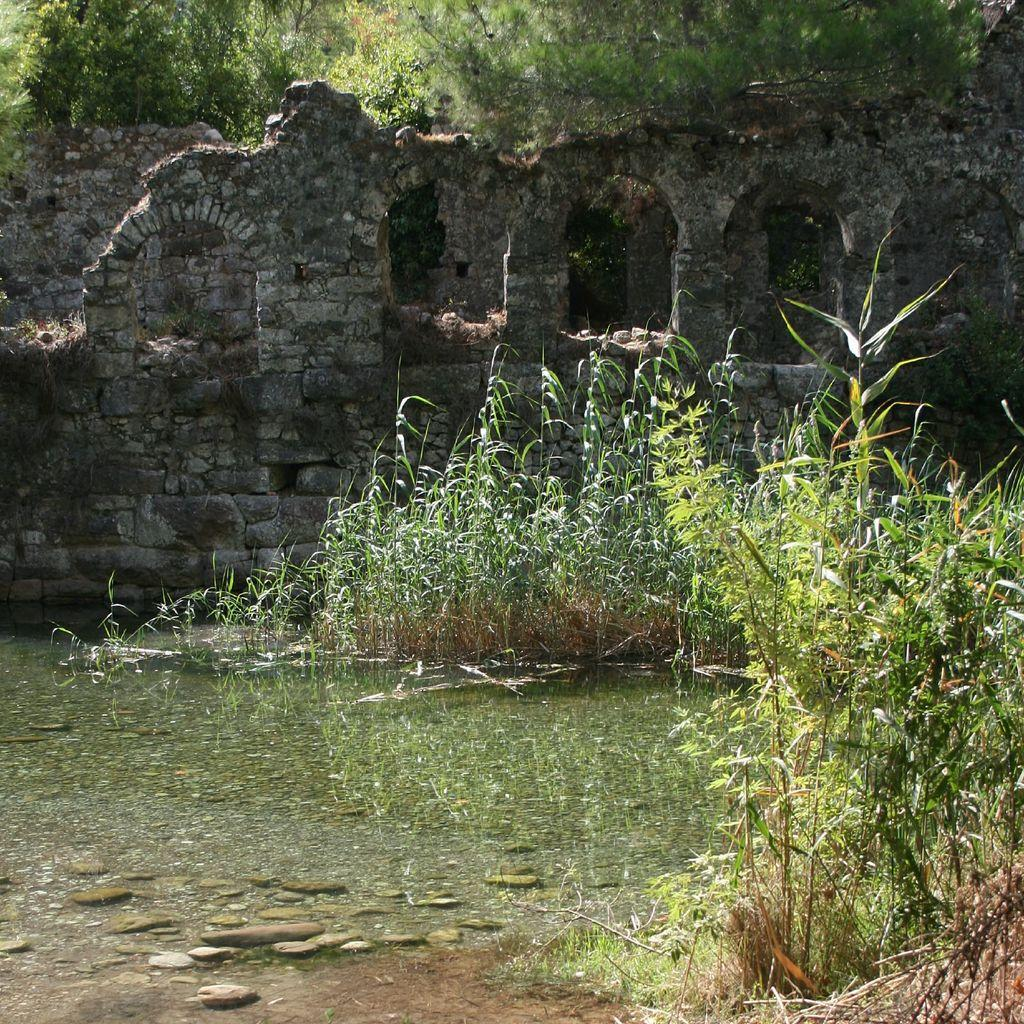What is the primary element in the image? There is water in the image. What can be seen near the water? There are plants near the water. What is visible in the background of the image? There is a wall and many trees in the background. What type of flowers are being discussed by the committee in the image? There is no committee or flowers present in the image. 